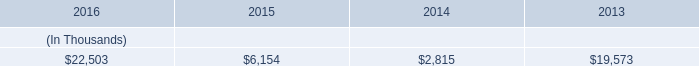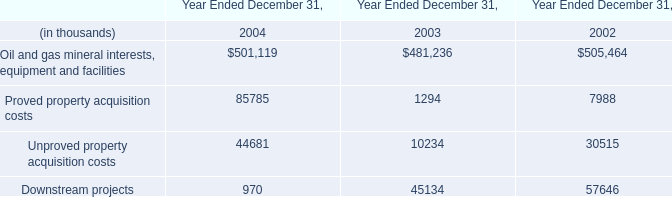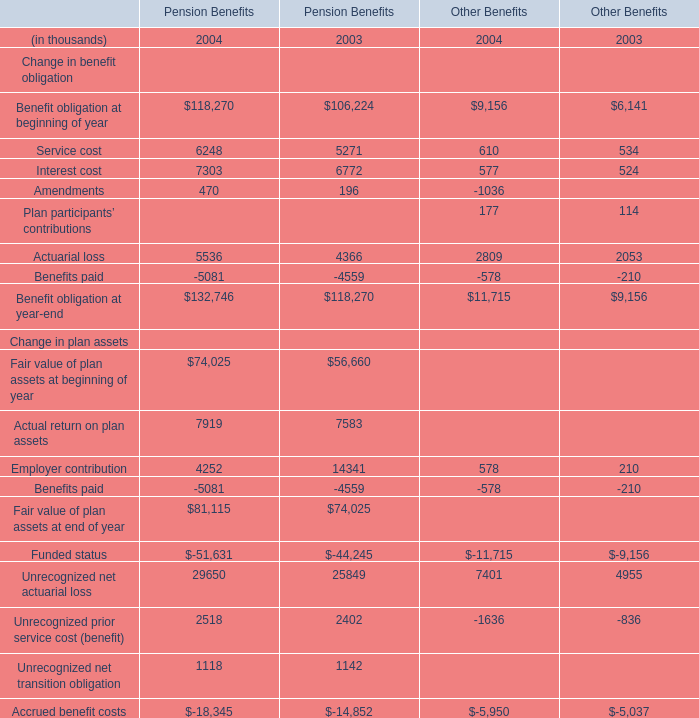What is the sum of Unproved property acquisition costs of Year Ended December 31, 2004, and Funded status Change in plan assets of Pension Benefits 2004 ? 
Computations: (44681.0 + 51631.0)
Answer: 96312.0. 